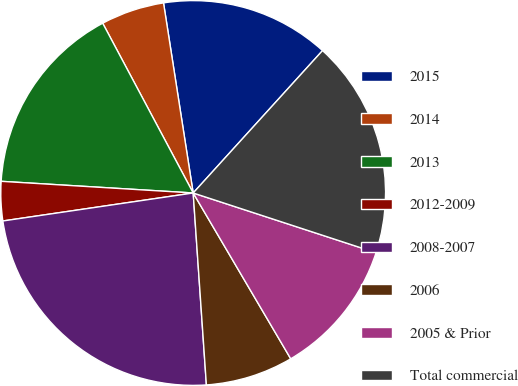Convert chart. <chart><loc_0><loc_0><loc_500><loc_500><pie_chart><fcel>2015<fcel>2014<fcel>2013<fcel>2012-2009<fcel>2008-2007<fcel>2006<fcel>2005 & Prior<fcel>Total commercial<nl><fcel>14.2%<fcel>5.33%<fcel>16.24%<fcel>3.29%<fcel>23.77%<fcel>7.37%<fcel>11.51%<fcel>18.29%<nl></chart> 